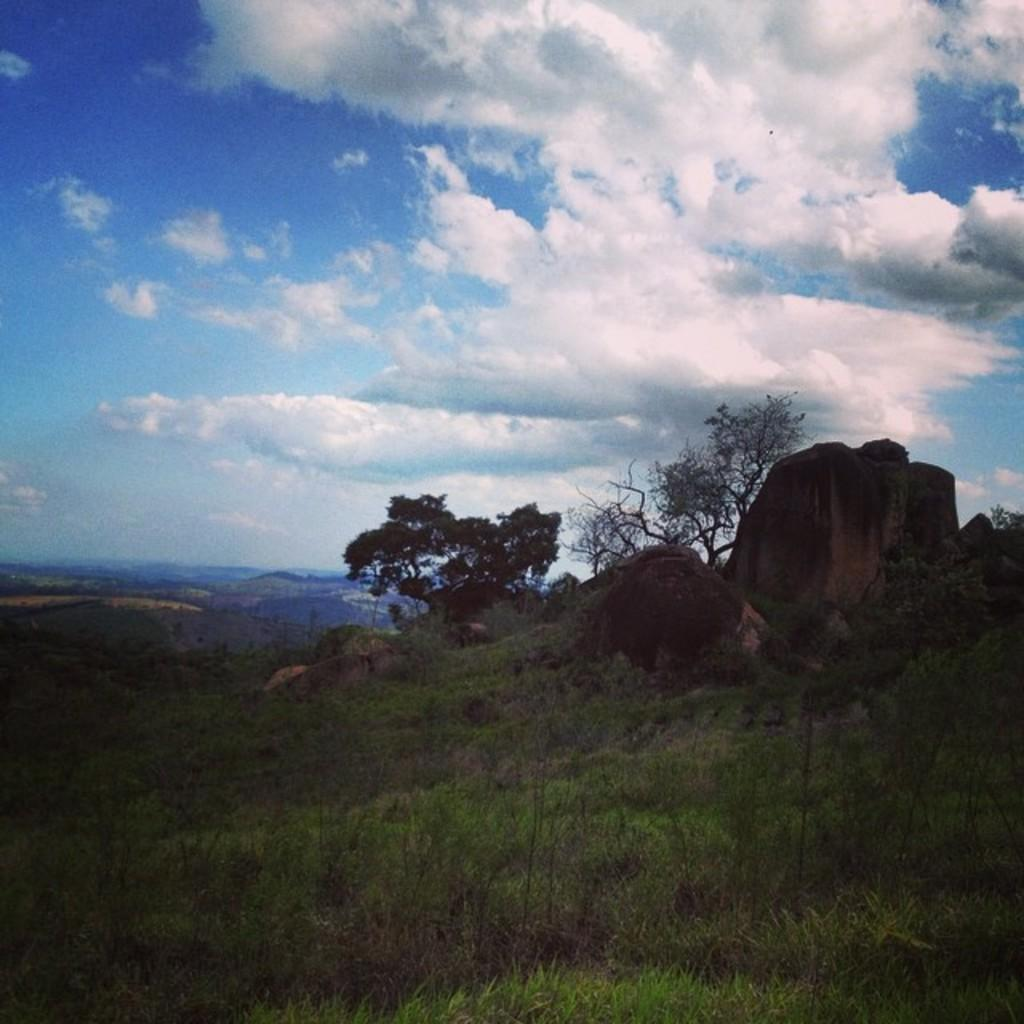What type of vegetation can be seen in the image? There is grass in the image. What other natural elements are present in the image? There are trees and hills in the image. What is visible in the background of the image? The sky is visible in the image. Where is the doctor standing with their medical shelf in the image? There is no doctor or medical shelf present in the image. What type of smashing activity is happening in the image? There is no smashing activity happening in the image. 